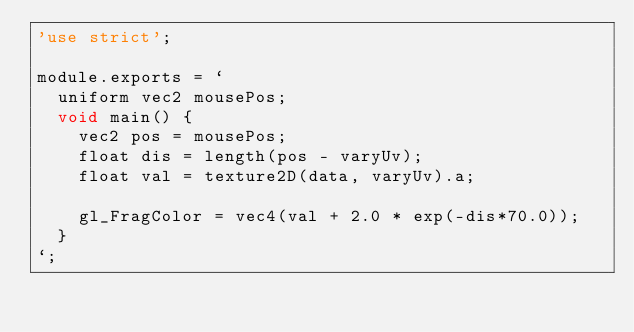Convert code to text. <code><loc_0><loc_0><loc_500><loc_500><_JavaScript_>'use strict';

module.exports = `
  uniform vec2 mousePos;
  void main() {
    vec2 pos = mousePos;
    float dis = length(pos - varyUv);
    float val = texture2D(data, varyUv).a;

    gl_FragColor = vec4(val + 2.0 * exp(-dis*70.0));
  }
`;
</code> 